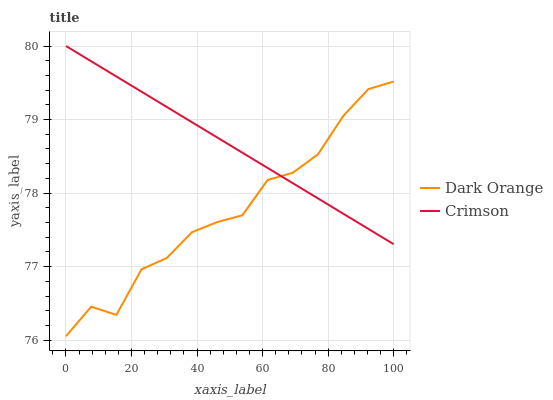Does Dark Orange have the minimum area under the curve?
Answer yes or no. Yes. Does Crimson have the maximum area under the curve?
Answer yes or no. Yes. Does Dark Orange have the maximum area under the curve?
Answer yes or no. No. Is Crimson the smoothest?
Answer yes or no. Yes. Is Dark Orange the roughest?
Answer yes or no. Yes. Is Dark Orange the smoothest?
Answer yes or no. No. Does Crimson have the highest value?
Answer yes or no. Yes. Does Dark Orange have the highest value?
Answer yes or no. No. Does Crimson intersect Dark Orange?
Answer yes or no. Yes. Is Crimson less than Dark Orange?
Answer yes or no. No. Is Crimson greater than Dark Orange?
Answer yes or no. No. 